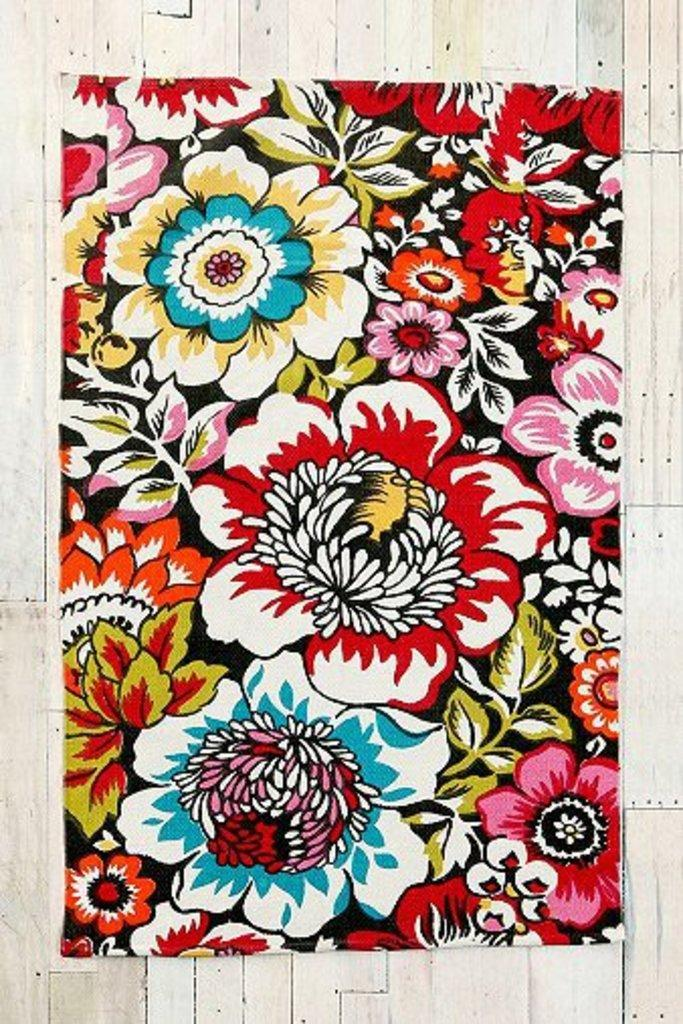What type of material is the main subject in the image made of? The main subject in the image is a colorful cloth. Where is the cloth located in the image? The cloth is on a wooden wall. How is the cloth positioned in the image? The cloth is in the center of the image. What is the weight of the tin container on the left side of the image? There is no tin container present in the image; it only features a colorful cloth on a wooden wall. 